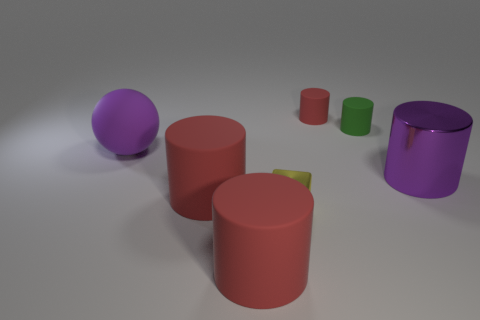Subtract all green matte cylinders. How many cylinders are left? 4 Subtract all red cylinders. How many cylinders are left? 2 Add 1 small purple cubes. How many objects exist? 8 Subtract all cylinders. How many objects are left? 2 Subtract 1 cylinders. How many cylinders are left? 4 Subtract all green spheres. Subtract all gray cylinders. How many spheres are left? 1 Subtract all green cubes. How many red cylinders are left? 3 Subtract all big red shiny cylinders. Subtract all purple things. How many objects are left? 5 Add 2 large cylinders. How many large cylinders are left? 5 Add 2 cyan metallic spheres. How many cyan metallic spheres exist? 2 